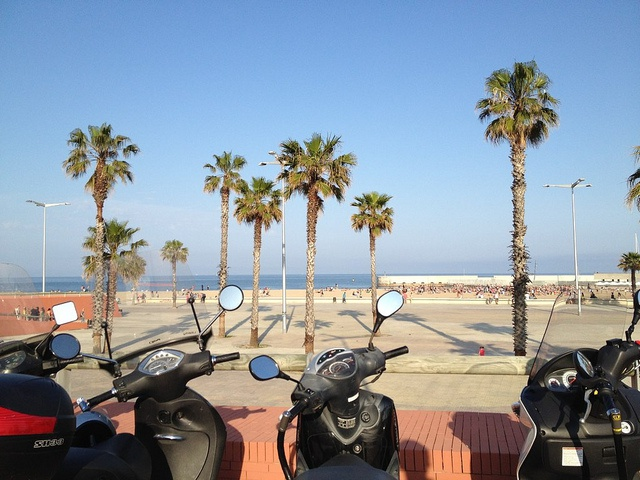Describe the objects in this image and their specific colors. I can see motorcycle in gray, black, white, and darkgray tones, motorcycle in gray, black, and tan tones, motorcycle in gray, black, darkgray, and white tones, people in gray, tan, and darkgray tones, and people in gray, lightpink, and tan tones in this image. 